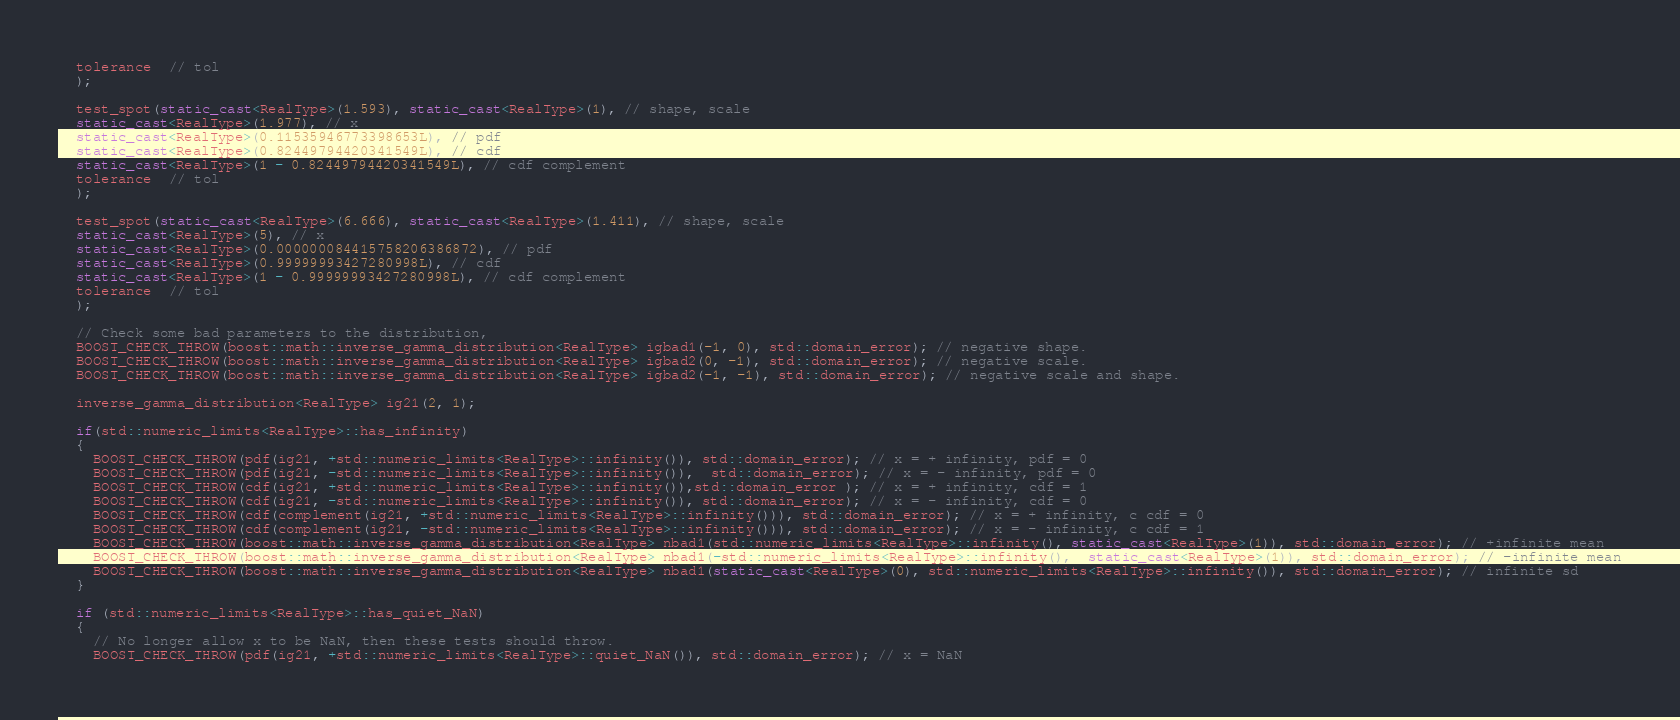<code> <loc_0><loc_0><loc_500><loc_500><_C++_>  tolerance  // tol
  );

  test_spot(static_cast<RealType>(1.593), static_cast<RealType>(1), // shape, scale
  static_cast<RealType>(1.977), // x
  static_cast<RealType>(0.11535946773398653L), // pdf
  static_cast<RealType>(0.82449794420341549L), // cdf
  static_cast<RealType>(1 - 0.82449794420341549L), // cdf complement
  tolerance  // tol
  );
  
  test_spot(static_cast<RealType>(6.666), static_cast<RealType>(1.411), // shape, scale
  static_cast<RealType>(5), // x
  static_cast<RealType>(0.000000084415758206386872), // pdf
  static_cast<RealType>(0.99999993427280998L), // cdf
  static_cast<RealType>(1 - 0.99999993427280998L), // cdf complement
  tolerance  // tol
  );

  // Check some bad parameters to the distribution,
  BOOST_CHECK_THROW(boost::math::inverse_gamma_distribution<RealType> igbad1(-1, 0), std::domain_error); // negative shape.
  BOOST_CHECK_THROW(boost::math::inverse_gamma_distribution<RealType> igbad2(0, -1), std::domain_error); // negative scale.
  BOOST_CHECK_THROW(boost::math::inverse_gamma_distribution<RealType> igbad2(-1, -1), std::domain_error); // negative scale and shape.

  inverse_gamma_distribution<RealType> ig21(2, 1);

  if(std::numeric_limits<RealType>::has_infinity)
  {
    BOOST_CHECK_THROW(pdf(ig21, +std::numeric_limits<RealType>::infinity()), std::domain_error); // x = + infinity, pdf = 0
    BOOST_CHECK_THROW(pdf(ig21, -std::numeric_limits<RealType>::infinity()),  std::domain_error); // x = - infinity, pdf = 0
    BOOST_CHECK_THROW(cdf(ig21, +std::numeric_limits<RealType>::infinity()),std::domain_error ); // x = + infinity, cdf = 1
    BOOST_CHECK_THROW(cdf(ig21, -std::numeric_limits<RealType>::infinity()), std::domain_error); // x = - infinity, cdf = 0
    BOOST_CHECK_THROW(cdf(complement(ig21, +std::numeric_limits<RealType>::infinity())), std::domain_error); // x = + infinity, c cdf = 0
    BOOST_CHECK_THROW(cdf(complement(ig21, -std::numeric_limits<RealType>::infinity())), std::domain_error); // x = - infinity, c cdf = 1
    BOOST_CHECK_THROW(boost::math::inverse_gamma_distribution<RealType> nbad1(std::numeric_limits<RealType>::infinity(), static_cast<RealType>(1)), std::domain_error); // +infinite mean
    BOOST_CHECK_THROW(boost::math::inverse_gamma_distribution<RealType> nbad1(-std::numeric_limits<RealType>::infinity(),  static_cast<RealType>(1)), std::domain_error); // -infinite mean
    BOOST_CHECK_THROW(boost::math::inverse_gamma_distribution<RealType> nbad1(static_cast<RealType>(0), std::numeric_limits<RealType>::infinity()), std::domain_error); // infinite sd
  }

  if (std::numeric_limits<RealType>::has_quiet_NaN)
  {
    // No longer allow x to be NaN, then these tests should throw.
    BOOST_CHECK_THROW(pdf(ig21, +std::numeric_limits<RealType>::quiet_NaN()), std::domain_error); // x = NaN</code> 